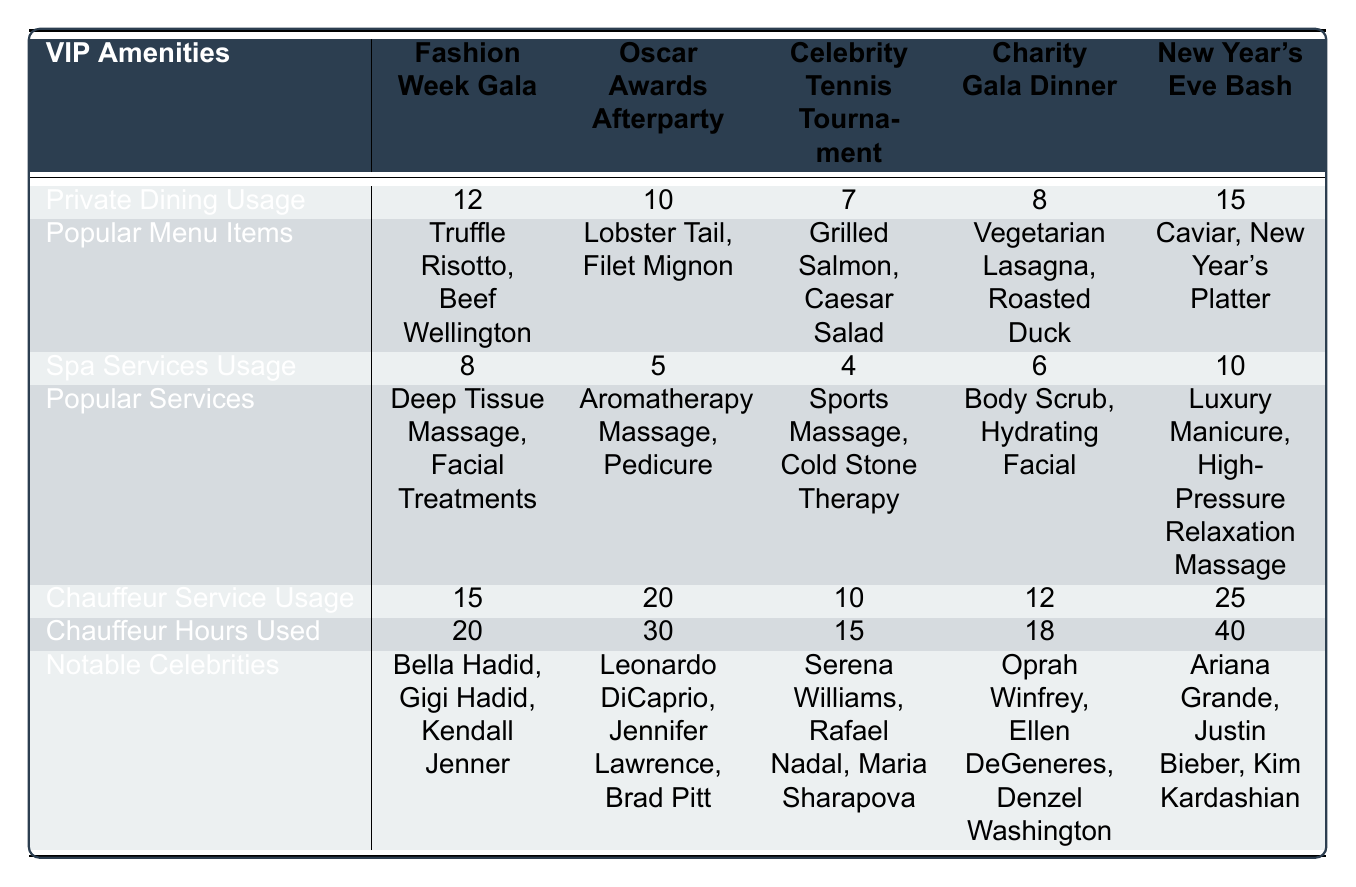What is the total usage count of private dining across all events? The private dining usage counts are 12, 10, 7, 8, and 15 for the respective events. Summing these gives us 12 + 10 + 7 + 8 + 15 = 52.
Answer: 52 Which event had the highest usage of spa services? The spa services usage counts are 8, 5, 4, 6, and 10 for the events. The highest usage count is 10 for the New Year's Eve Bash.
Answer: New Year's Eve Bash Did more celebrities attend the Fashion Week Gala than the Oscar Awards Afterparty? The Fashion Week Gala had 3 celebrities and the Oscar Awards Afterparty also had 3 celebrities. Thus, they are equal in the number of attending celebrities.
Answer: No Which VIP amenity had the highest usage on New Year's Eve Bash? Comparing the usage counts of private dining (15), spa services (10), and chauffeur service (25) shows that chauffeur service had the highest usage at 25.
Answer: Chauffeur service What are the popular menu items at the Oscar Awards Afterparty? The popular menu items listed are Lobster Tail, Filet Mignon, and Panna Cotta.
Answer: Lobster Tail, Filet Mignon, Panna Cotta What is the total chauffeur hours used for the Charity Gala Dinner and the Celebrity Tennis Tournament? The chauffeur hours used for the Charity Gala Dinner is 18, and for the Celebrity Tennis Tournament, it is 15. Summing these gives 18 + 15 = 33 hours.
Answer: 33 Which event had the least number of private dining usages? The private dining usage counts are 12, 10, 7, 8, and 15. The least count is 7 for the Celebrity Tennis Tournament.
Answer: Celebrity Tennis Tournament Is the total usage count of chauffeur services across all events greater than 70? The chauffeur service usage counts are 15, 20, 10, 12, and 25. Summing these gives 15 + 20 + 10 + 12 + 25 = 92. 92 is greater than 70.
Answer: Yes What spa service was most popular during the Fashion Week Gala? The popular services for the Fashion Week Gala are Deep Tissue Massage and Facial Treatments. Since two services are listed, they are both considered popular.
Answer: Deep Tissue Massage, Facial Treatments How much more chauffeur service did the New Year's Eve Bash use compared to the Charity Gala Dinner? The chauffeur service usage for New Year's Eve Bash is 25 and for Charity Gala Dinner is 12. The difference is 25 - 12 = 13.
Answer: 13 